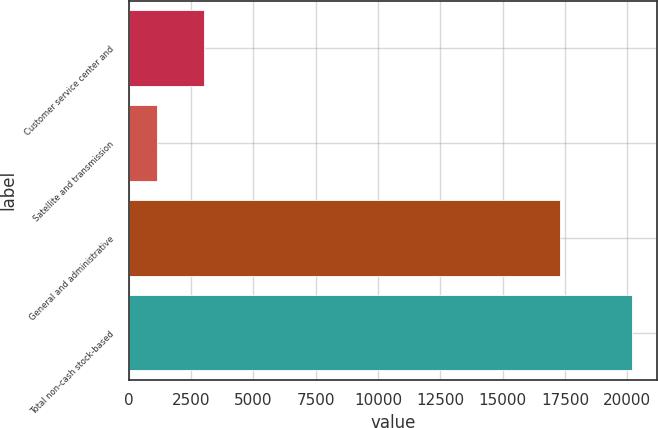Convert chart to OTSL. <chart><loc_0><loc_0><loc_500><loc_500><bar_chart><fcel>Customer service center and<fcel>Satellite and transmission<fcel>General and administrative<fcel>Total non-cash stock-based<nl><fcel>3020.8<fcel>1115<fcel>17291<fcel>20173<nl></chart> 